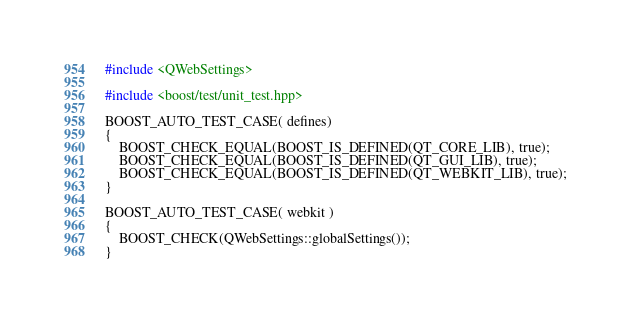<code> <loc_0><loc_0><loc_500><loc_500><_C++_>
#include <QWebSettings>

#include <boost/test/unit_test.hpp>

BOOST_AUTO_TEST_CASE( defines)
{
    BOOST_CHECK_EQUAL(BOOST_IS_DEFINED(QT_CORE_LIB), true);
    BOOST_CHECK_EQUAL(BOOST_IS_DEFINED(QT_GUI_LIB), true);
    BOOST_CHECK_EQUAL(BOOST_IS_DEFINED(QT_WEBKIT_LIB), true);
}

BOOST_AUTO_TEST_CASE( webkit )
{
    BOOST_CHECK(QWebSettings::globalSettings());
}
</code> 